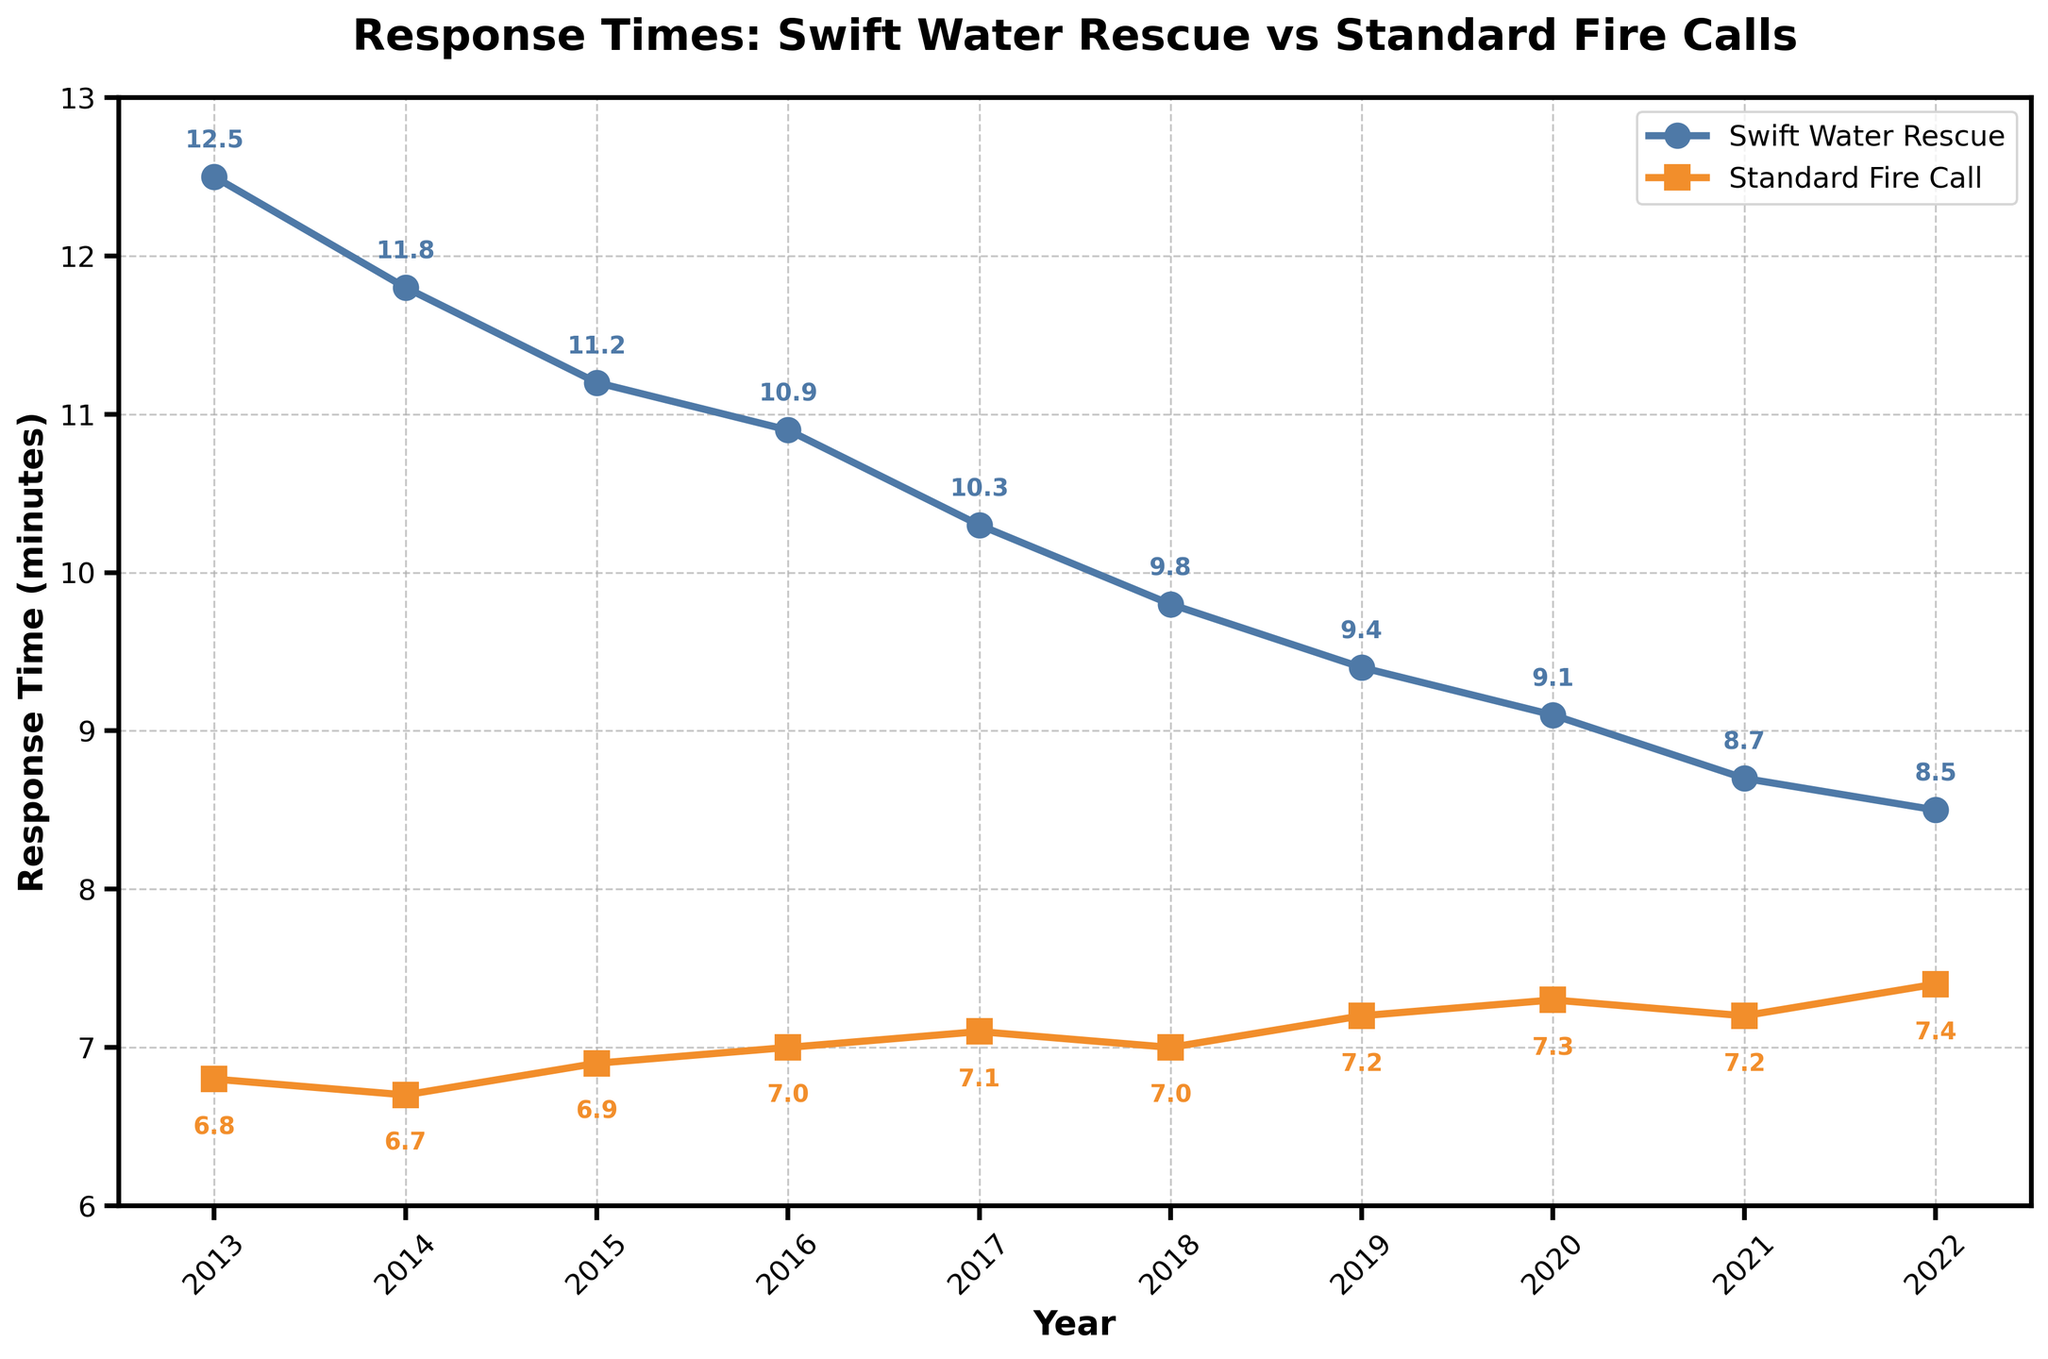Which type of emergency call had a higher response time in 2013? By looking at the markers for 2013 on the line chart, we can see that the response time for swift water rescue was higher. The blue line representing swift water rescue is above the orange line representing standard fire calls.
Answer: Swift water rescue How did the response time for swift water rescue change from 2013 to 2022? To determine the change, we need to look at the values for 2013 and 2022 from the blue line. In 2013, the response time was 12.5 minutes, and in 2022, it was 8.5 minutes. The change is 12.5 - 8.5 = 4.0 minutes.
Answer: Decreased by 4.0 minutes What was the trend in response times for standard fire calls from 2013 to 2022? Observing the orange line from 2013 to 2022, the response time for standard fire calls shows a slight increase over the years, from 6.8 minutes in 2013 to 7.4 minutes in 2022.
Answer: Slightly increasing Which year had the lowest swift water rescue response time? By examining the blue line on the chart, the lowest point corresponds to the year 2022 with a response time of 8.5 minutes.
Answer: 2022 Compare the response times for swift water rescue and standard fire calls in 2018. In 2018, the blue line is at 9.8 minutes for swift water rescue, and the orange line is at 7.0 minutes for standard fire calls.
Answer: Swift water rescue was 9.8 minutes, and standard fire calls were 7.0 minutes What is the difference in response times between swift water rescue and standard fire calls in 2020? Check the markers on the chart for 2020: the blue line indicates 9.1 minutes for swift water rescue and the orange line indicates 7.3 minutes for standard fire calls. The difference is 9.1 - 7.3 = 1.8 minutes.
Answer: 1.8 minutes Between which consecutive years was the largest drop in response time for swift water rescue? By examining the blue line for the biggest downward slope, the largest drop occurs between 2017 and 2018, decreasing from 10.3 to 9.8 minutes, a drop of 0.5 minutes.
Answer: 2017 to 2018 How much did the standard fire call response time increase from 2013 to 2022? From the chart, note the response times for standard fire calls in 2013 (6.8 minutes) and 2022 (7.4 minutes). The increase is 7.4 - 6.8 = 0.6 minutes.
Answer: Increased by 0.6 minutes What was the average response time for swift water rescue over these years? To find the average, sum the response times for swift water rescue: 12.5 + 11.8 + 11.2 + 10.9 + 10.3 + 9.8 + 9.4 + 9.1 + 8.7 + 8.5 = 102.2. Divide by the number of years (10): 102.2 / 10 = 10.22 minutes.
Answer: 10.22 minutes 